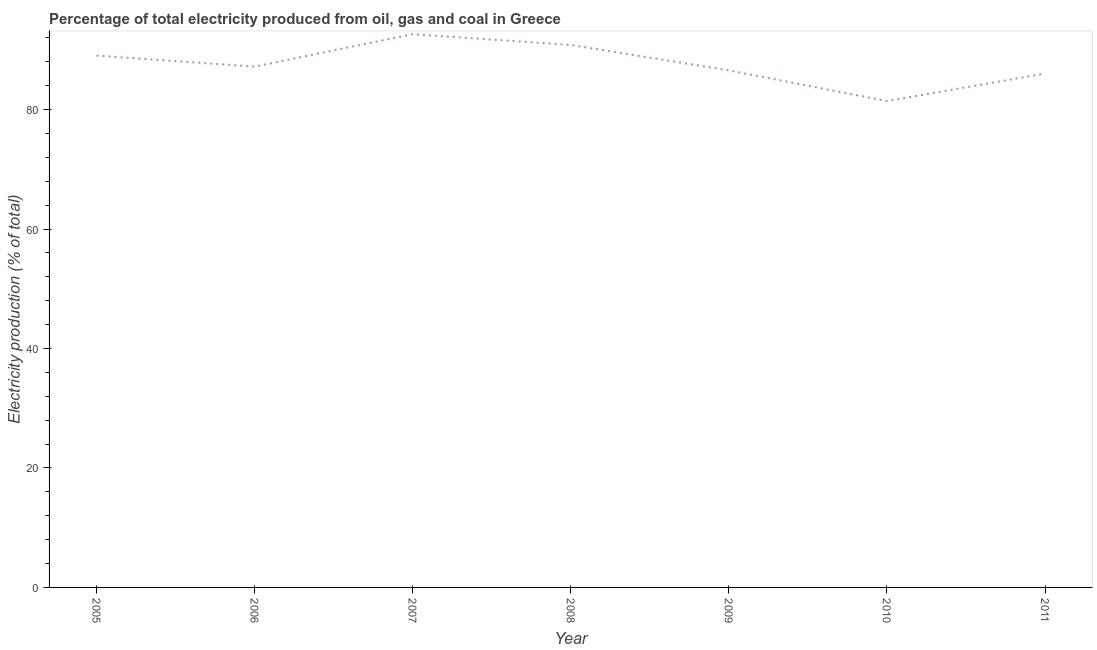What is the electricity production in 2006?
Provide a succinct answer. 87.2. Across all years, what is the maximum electricity production?
Ensure brevity in your answer.  92.63. Across all years, what is the minimum electricity production?
Make the answer very short. 81.43. In which year was the electricity production maximum?
Make the answer very short. 2007. What is the sum of the electricity production?
Ensure brevity in your answer.  613.77. What is the difference between the electricity production in 2006 and 2010?
Your answer should be compact. 5.76. What is the average electricity production per year?
Offer a very short reply. 87.68. What is the median electricity production?
Ensure brevity in your answer.  87.2. Do a majority of the years between 2006 and 2008 (inclusive) have electricity production greater than 12 %?
Give a very brief answer. Yes. What is the ratio of the electricity production in 2009 to that in 2011?
Offer a terse response. 1.01. Is the electricity production in 2007 less than that in 2008?
Your answer should be compact. No. Is the difference between the electricity production in 2008 and 2009 greater than the difference between any two years?
Your answer should be compact. No. What is the difference between the highest and the second highest electricity production?
Offer a very short reply. 1.8. Is the sum of the electricity production in 2006 and 2008 greater than the maximum electricity production across all years?
Ensure brevity in your answer.  Yes. What is the difference between the highest and the lowest electricity production?
Make the answer very short. 11.2. In how many years, is the electricity production greater than the average electricity production taken over all years?
Ensure brevity in your answer.  3. Does the electricity production monotonically increase over the years?
Ensure brevity in your answer.  No. How many years are there in the graph?
Your answer should be compact. 7. Does the graph contain any zero values?
Provide a short and direct response. No. Does the graph contain grids?
Provide a short and direct response. No. What is the title of the graph?
Give a very brief answer. Percentage of total electricity produced from oil, gas and coal in Greece. What is the label or title of the X-axis?
Give a very brief answer. Year. What is the label or title of the Y-axis?
Give a very brief answer. Electricity production (% of total). What is the Electricity production (% of total) in 2005?
Keep it short and to the point. 89.05. What is the Electricity production (% of total) in 2006?
Keep it short and to the point. 87.2. What is the Electricity production (% of total) in 2007?
Provide a succinct answer. 92.63. What is the Electricity production (% of total) of 2008?
Give a very brief answer. 90.83. What is the Electricity production (% of total) of 2009?
Your response must be concise. 86.57. What is the Electricity production (% of total) of 2010?
Provide a short and direct response. 81.43. What is the Electricity production (% of total) of 2011?
Offer a very short reply. 86.05. What is the difference between the Electricity production (% of total) in 2005 and 2006?
Provide a succinct answer. 1.85. What is the difference between the Electricity production (% of total) in 2005 and 2007?
Your response must be concise. -3.58. What is the difference between the Electricity production (% of total) in 2005 and 2008?
Your response must be concise. -1.78. What is the difference between the Electricity production (% of total) in 2005 and 2009?
Your answer should be very brief. 2.48. What is the difference between the Electricity production (% of total) in 2005 and 2010?
Offer a very short reply. 7.62. What is the difference between the Electricity production (% of total) in 2005 and 2011?
Your response must be concise. 3. What is the difference between the Electricity production (% of total) in 2006 and 2007?
Your answer should be very brief. -5.44. What is the difference between the Electricity production (% of total) in 2006 and 2008?
Your answer should be compact. -3.63. What is the difference between the Electricity production (% of total) in 2006 and 2009?
Provide a short and direct response. 0.63. What is the difference between the Electricity production (% of total) in 2006 and 2010?
Give a very brief answer. 5.76. What is the difference between the Electricity production (% of total) in 2006 and 2011?
Provide a succinct answer. 1.15. What is the difference between the Electricity production (% of total) in 2007 and 2008?
Your response must be concise. 1.8. What is the difference between the Electricity production (% of total) in 2007 and 2009?
Your response must be concise. 6.06. What is the difference between the Electricity production (% of total) in 2007 and 2010?
Keep it short and to the point. 11.2. What is the difference between the Electricity production (% of total) in 2007 and 2011?
Offer a terse response. 6.59. What is the difference between the Electricity production (% of total) in 2008 and 2009?
Provide a short and direct response. 4.26. What is the difference between the Electricity production (% of total) in 2008 and 2010?
Your answer should be compact. 9.4. What is the difference between the Electricity production (% of total) in 2008 and 2011?
Keep it short and to the point. 4.78. What is the difference between the Electricity production (% of total) in 2009 and 2010?
Your response must be concise. 5.14. What is the difference between the Electricity production (% of total) in 2009 and 2011?
Your answer should be compact. 0.52. What is the difference between the Electricity production (% of total) in 2010 and 2011?
Provide a short and direct response. -4.61. What is the ratio of the Electricity production (% of total) in 2005 to that in 2006?
Ensure brevity in your answer.  1.02. What is the ratio of the Electricity production (% of total) in 2005 to that in 2007?
Your answer should be compact. 0.96. What is the ratio of the Electricity production (% of total) in 2005 to that in 2008?
Give a very brief answer. 0.98. What is the ratio of the Electricity production (% of total) in 2005 to that in 2010?
Offer a very short reply. 1.09. What is the ratio of the Electricity production (% of total) in 2005 to that in 2011?
Provide a short and direct response. 1.03. What is the ratio of the Electricity production (% of total) in 2006 to that in 2007?
Keep it short and to the point. 0.94. What is the ratio of the Electricity production (% of total) in 2006 to that in 2008?
Provide a short and direct response. 0.96. What is the ratio of the Electricity production (% of total) in 2006 to that in 2010?
Your answer should be very brief. 1.07. What is the ratio of the Electricity production (% of total) in 2007 to that in 2009?
Give a very brief answer. 1.07. What is the ratio of the Electricity production (% of total) in 2007 to that in 2010?
Ensure brevity in your answer.  1.14. What is the ratio of the Electricity production (% of total) in 2007 to that in 2011?
Your answer should be compact. 1.08. What is the ratio of the Electricity production (% of total) in 2008 to that in 2009?
Keep it short and to the point. 1.05. What is the ratio of the Electricity production (% of total) in 2008 to that in 2010?
Provide a succinct answer. 1.11. What is the ratio of the Electricity production (% of total) in 2008 to that in 2011?
Offer a very short reply. 1.06. What is the ratio of the Electricity production (% of total) in 2009 to that in 2010?
Give a very brief answer. 1.06. What is the ratio of the Electricity production (% of total) in 2009 to that in 2011?
Give a very brief answer. 1.01. What is the ratio of the Electricity production (% of total) in 2010 to that in 2011?
Make the answer very short. 0.95. 